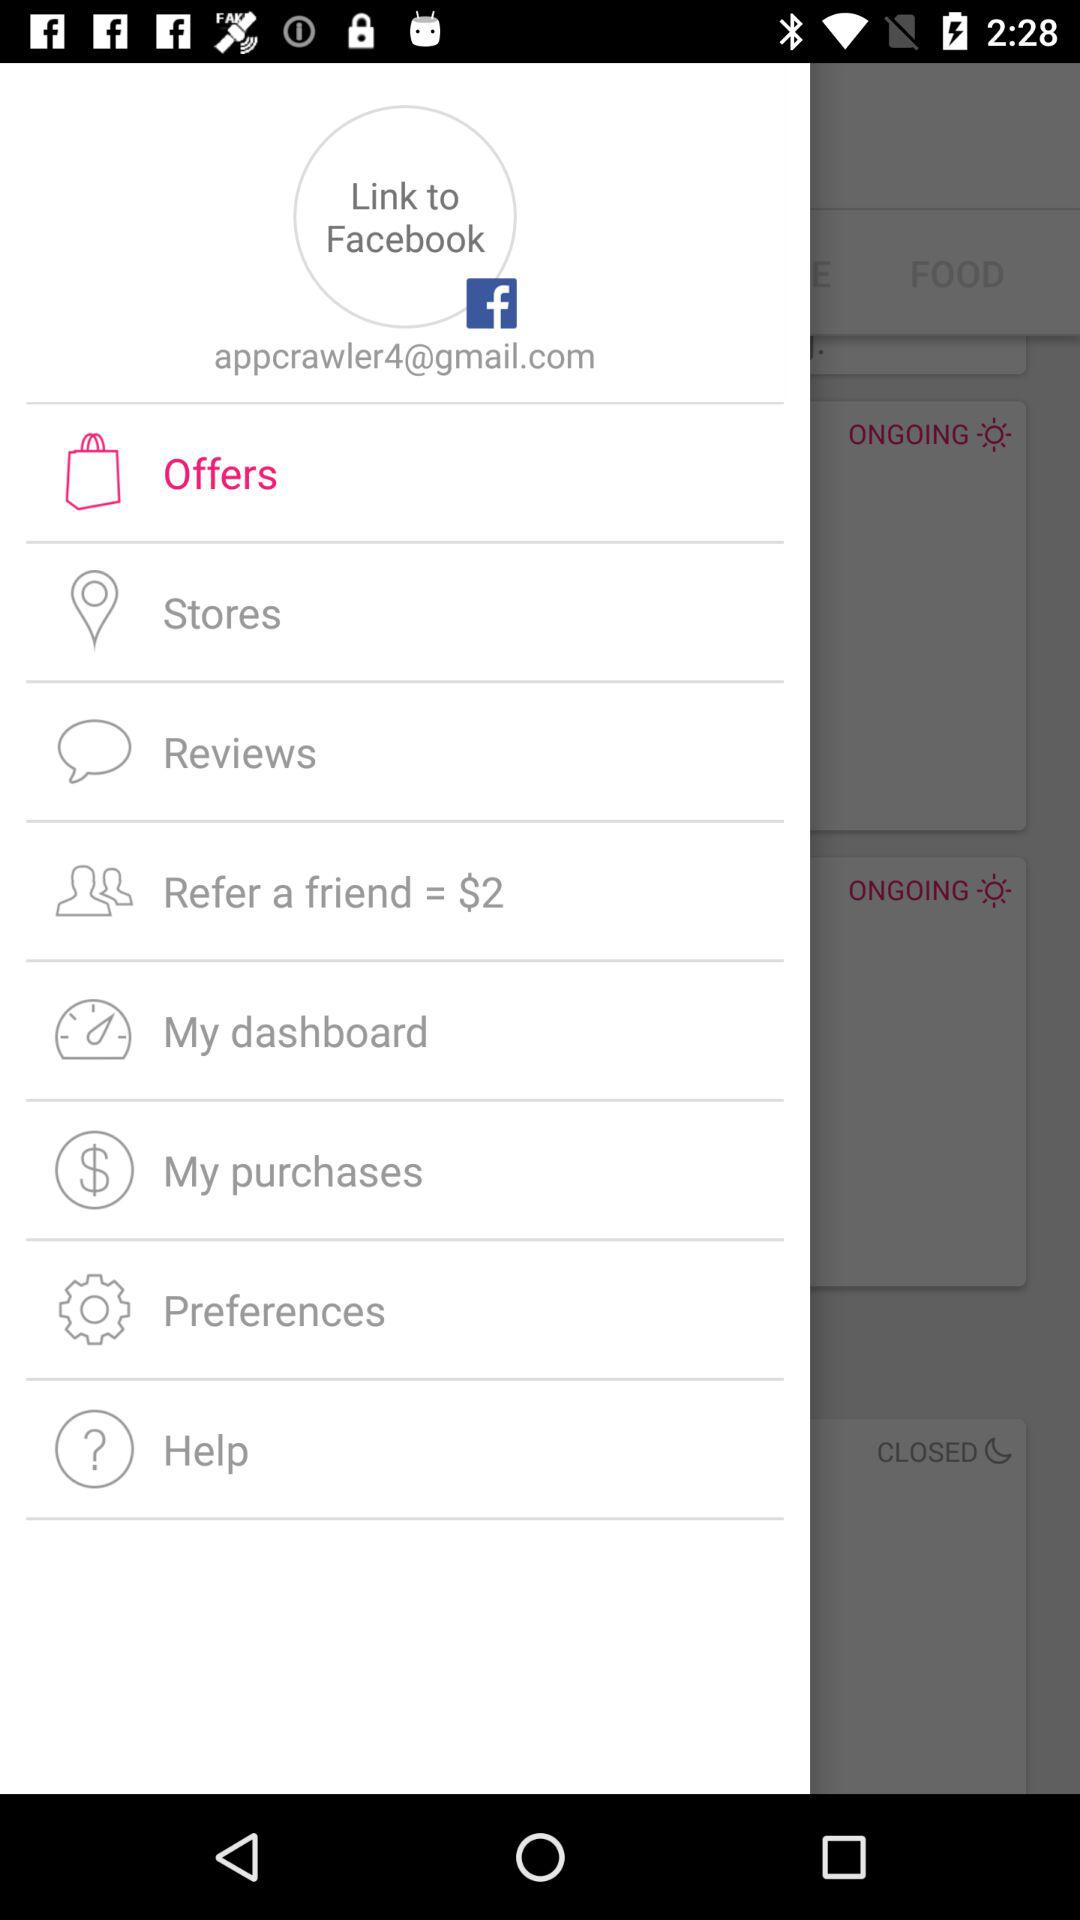Through what application can users link their accounts? Users can link their accounts to "Facebook". 